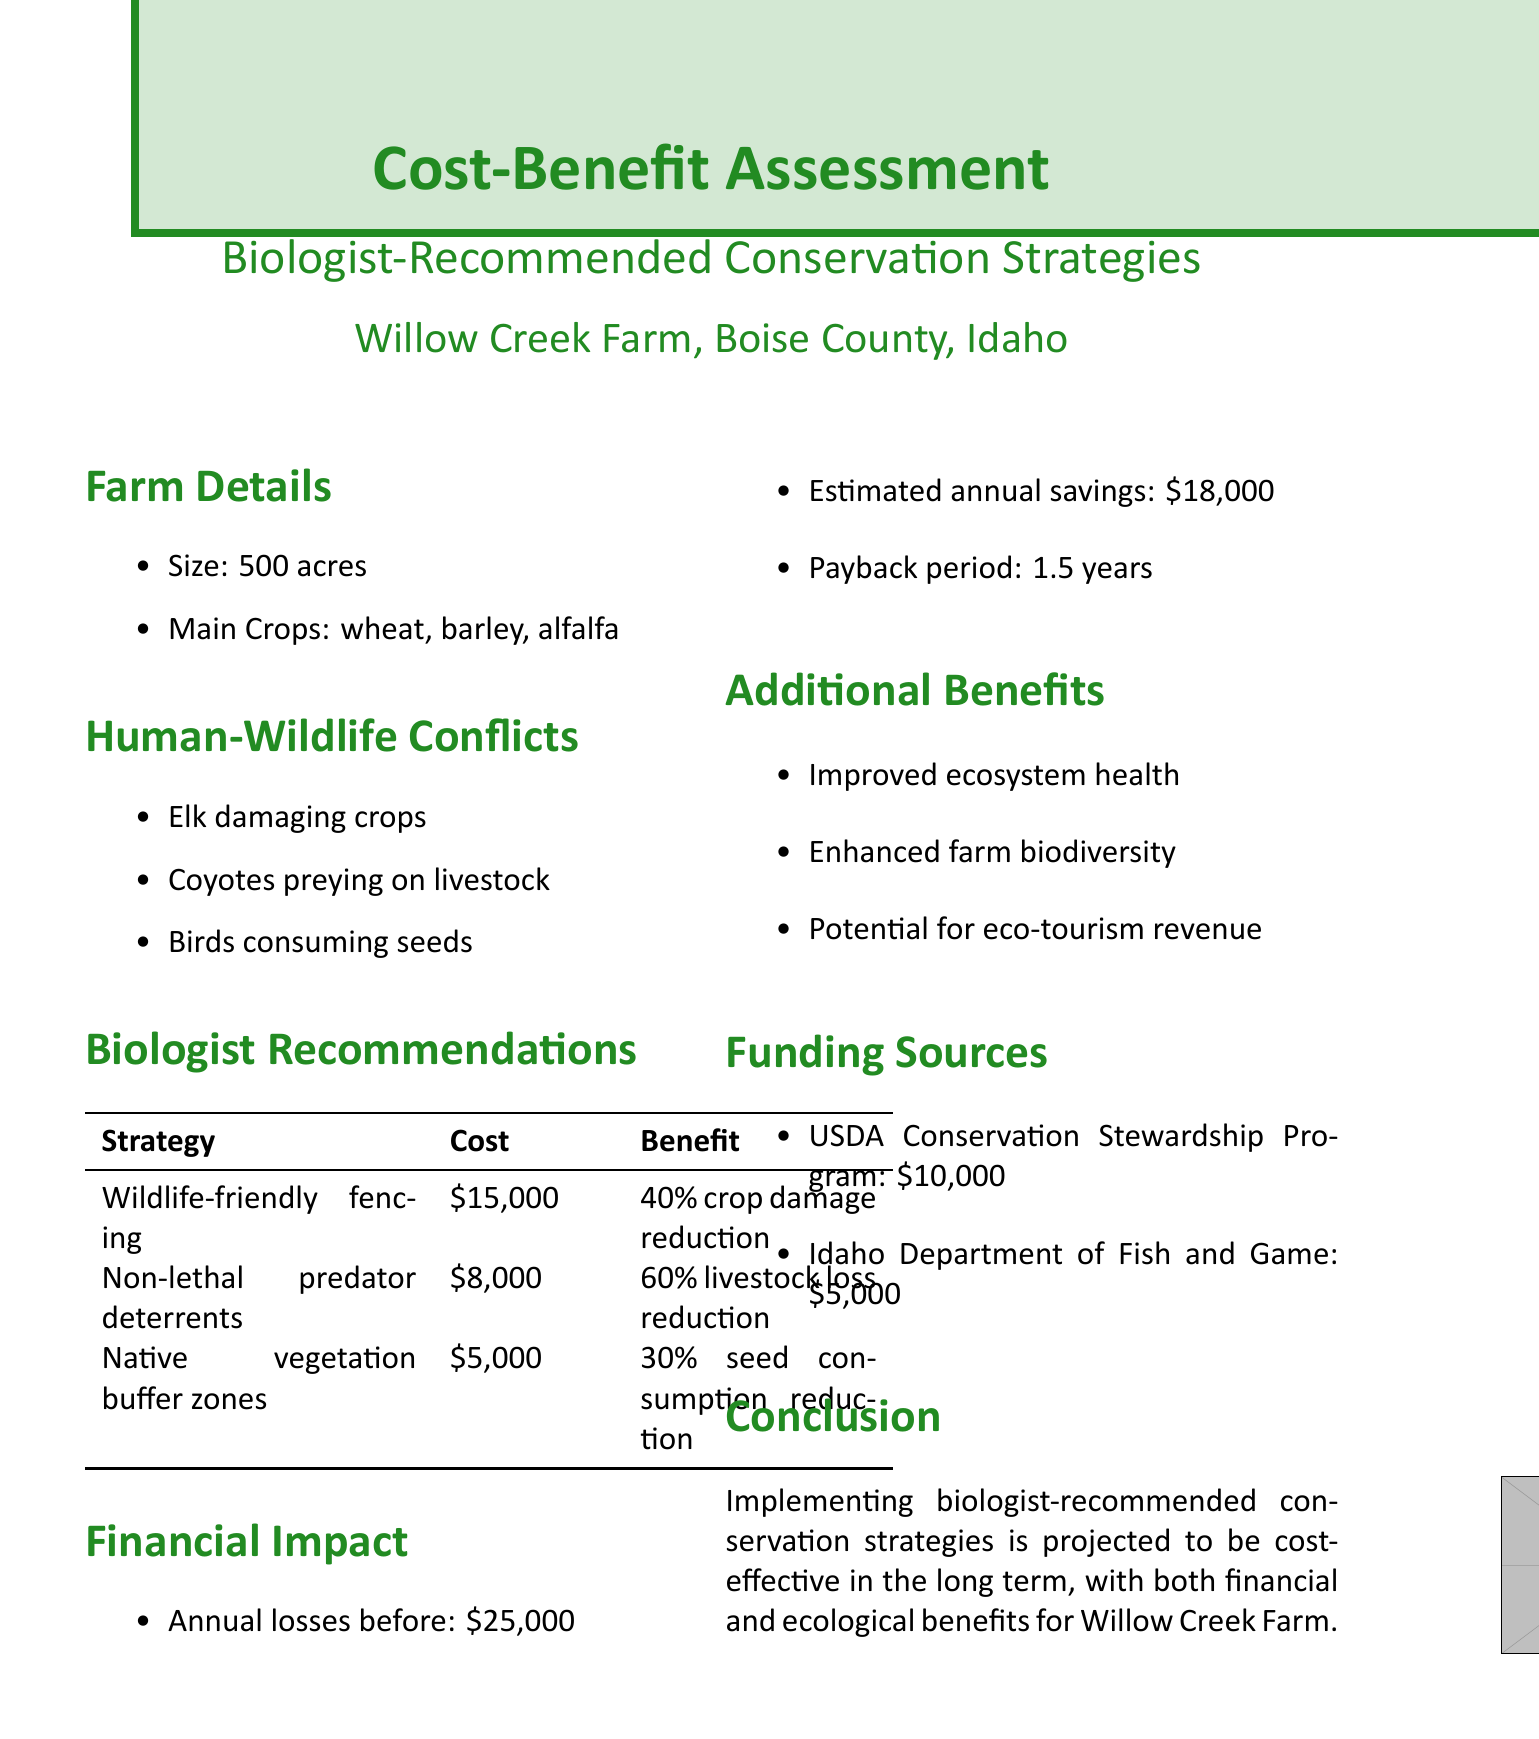what is the estimated cost of installing wildlife-friendly fencing? The document lists the estimated cost of installing wildlife-friendly fencing as $15,000.
Answer: $15,000 what is the potential benefit of planting buffer zones with native vegetation? The potential benefit listed for this strategy is a reduction in seed consumption by birds by 30%.
Answer: 30% how much are the annual losses before implementing the conservation strategies? The annual losses before implementation are stated to be $25,000.
Answer: $25,000 what is the payback period for the implemented strategies? The payback period for the implemented strategies is mentioned as 1.5 years.
Answer: 1.5 years which organization provides a potential grant of $10,000? The USDA Conservation Stewardship Program is specified as providing a potential grant of $10,000.
Answer: USDA Conservation Stewardship Program what are the two main crops grown on Willow Creek Farm? The main crops grown on the farm are wheat and barley.
Answer: wheat, barley what percentage reduction in livestock losses is expected from implementing non-lethal predator deterrents? The document projects a 60% decrease in livestock losses from this strategy.
Answer: 60% what is one of the additional benefits mentioned in the report? The report lists improved ecosystem health as one of the additional benefits.
Answer: Improved ecosystem health 